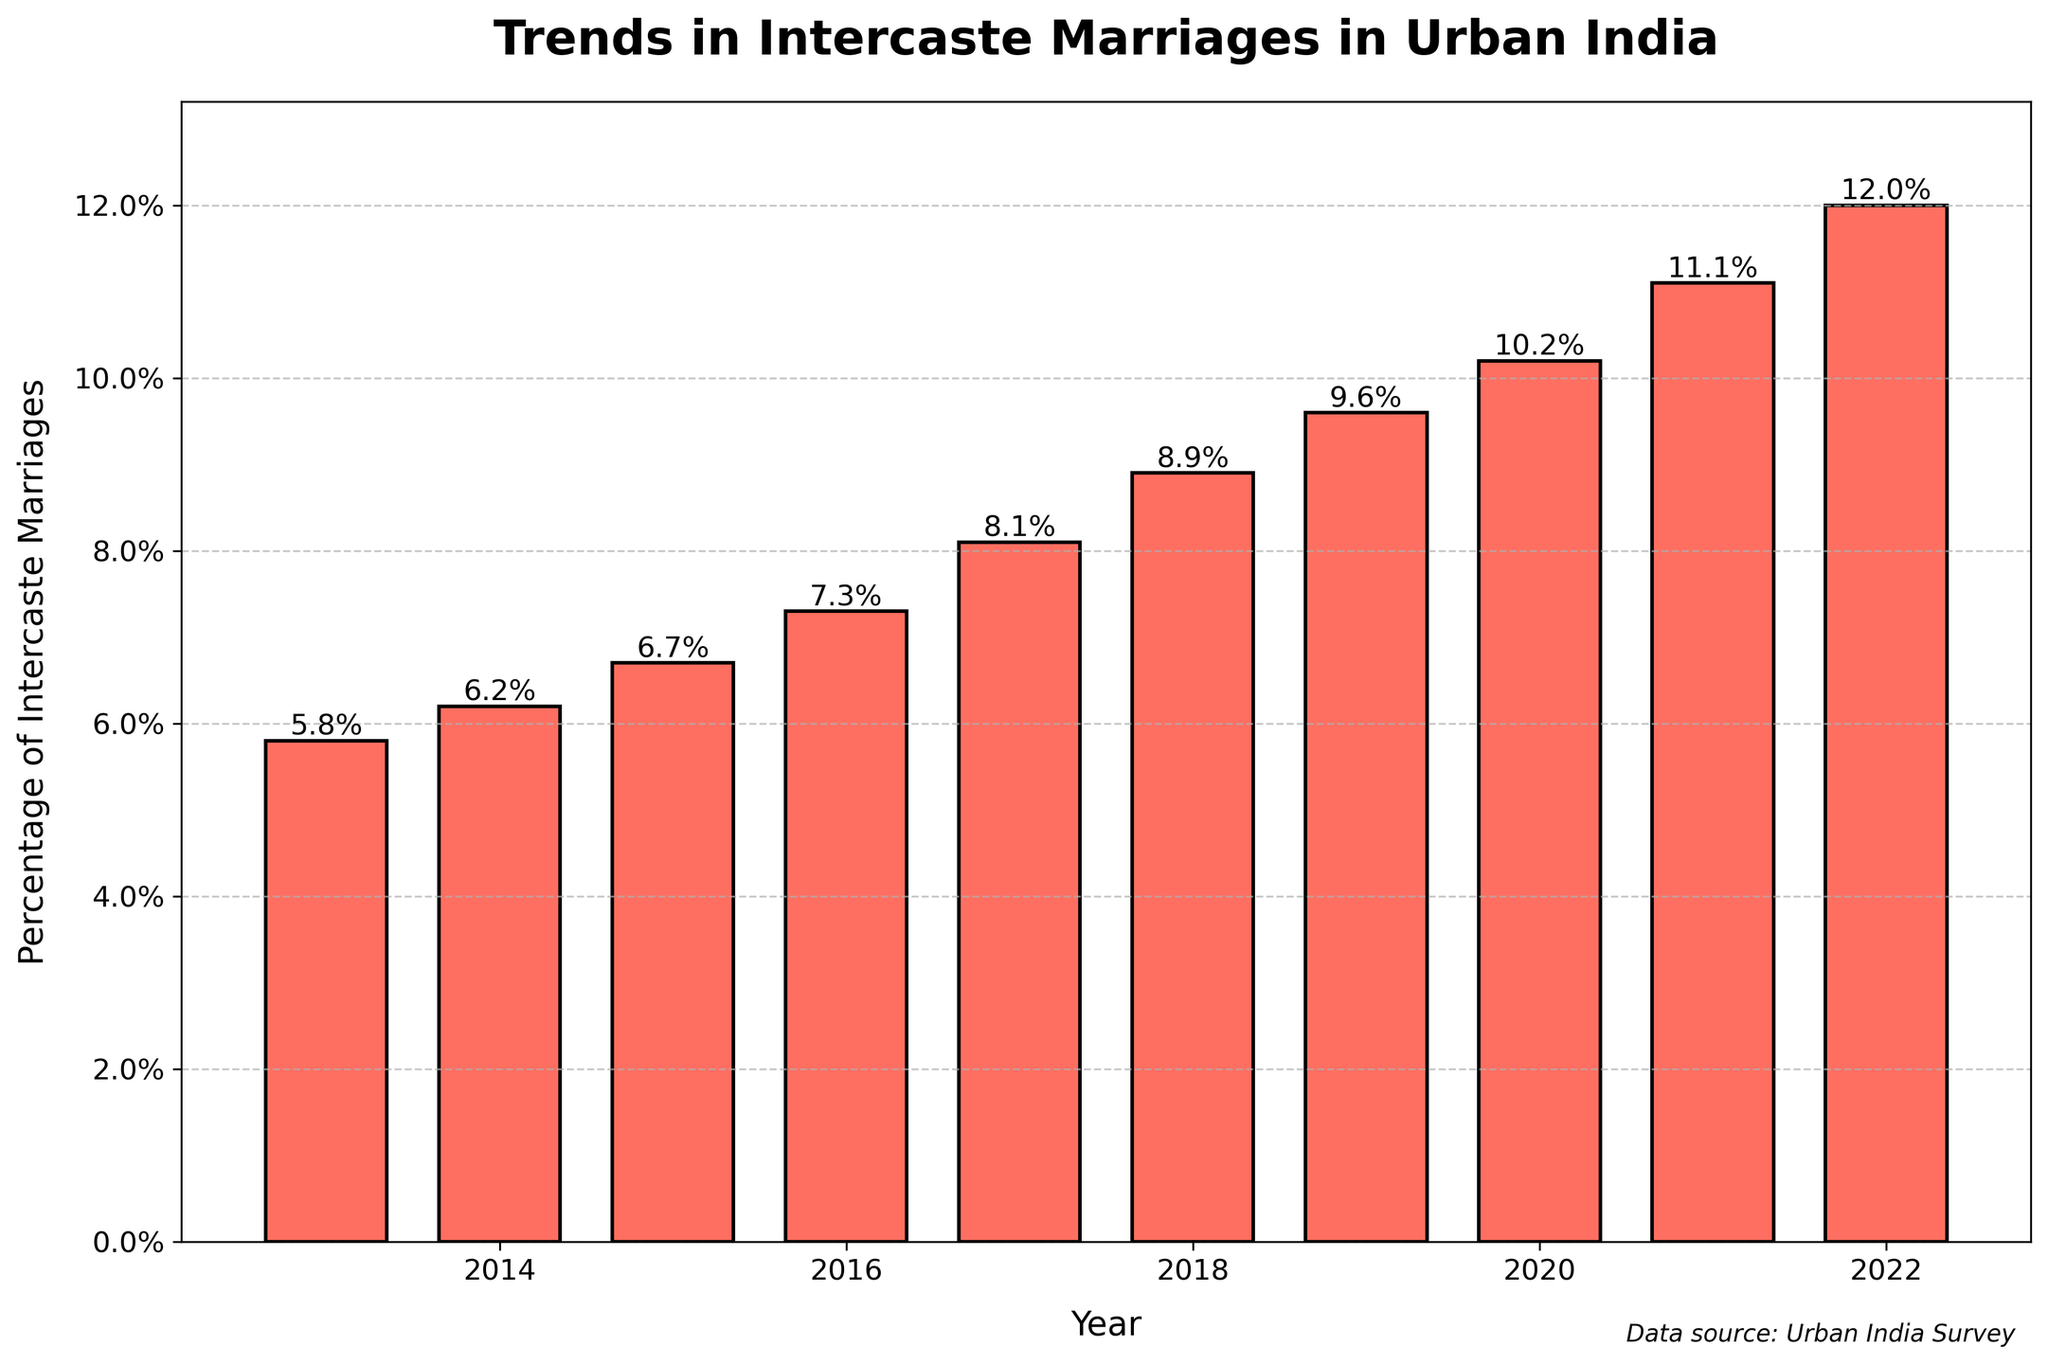Which year had the highest percentage of intercaste marriages? Look at the bar that reaches the highest point in the plot. From the figure, it's clear that the year 2022 has the highest percentage.
Answer: 2022 How much did the percentage of intercaste marriages increase from 2013 to 2022? Identify the percentages for the years 2013 and 2022. Subtract the 2013 percentage (5.8%) from the 2022 percentage (12.0%).
Answer: 6.2% On which year did the percentage of intercaste marriages first exceed 10%? Look for the first instance where the value is above 10% on the y-axis. The value first exceeds 10% in 2020.
Answer: 2020 What is the average percentage of intercaste marriages over the decade shown? Sum the percentages from 2013 to 2022 and then divide by 10. The calculations are (5.8+6.2+6.7+7.3+8.1+8.9+9.6+10.2+11.1+12.0) / 10 = 8.59.
Answer: 8.59% Which year witnessed the largest year-over-year increase in the percentage of intercaste marriages? Calculate the difference each year and find the maximum increase. The largest increase is from 2016 (7.3%) to 2017 (8.1%), which is 0.8%.
Answer: 2017 In which two consecutive years did the percentage of intercaste marriages first consistently increase by more than 0.5%? Check the increase between each consecutive year. From 2014 to 2015 it increased by 0.5%, then from 2015 to 2016 it also increased by 0.6%. This sequence starts from 2014 to 2016.
Answer: 2014 to 2016 Describe the change in the percentage of intercaste marriages from 2017 to 2018. Look at the heights of the bars for 2017 and 2018. The percentage increased from 8.1% to 8.9%. 8.9 - 8.1 = 0.8%.
Answer: 0.8% increase How many years had a percentage of intercaste marriages of at least 8%? Count the number of years where the percentage is 8% or above. The years 2017, 2018, 2019, 2020, 2021, and 2022 meet this criterion.
Answer: 6 years 